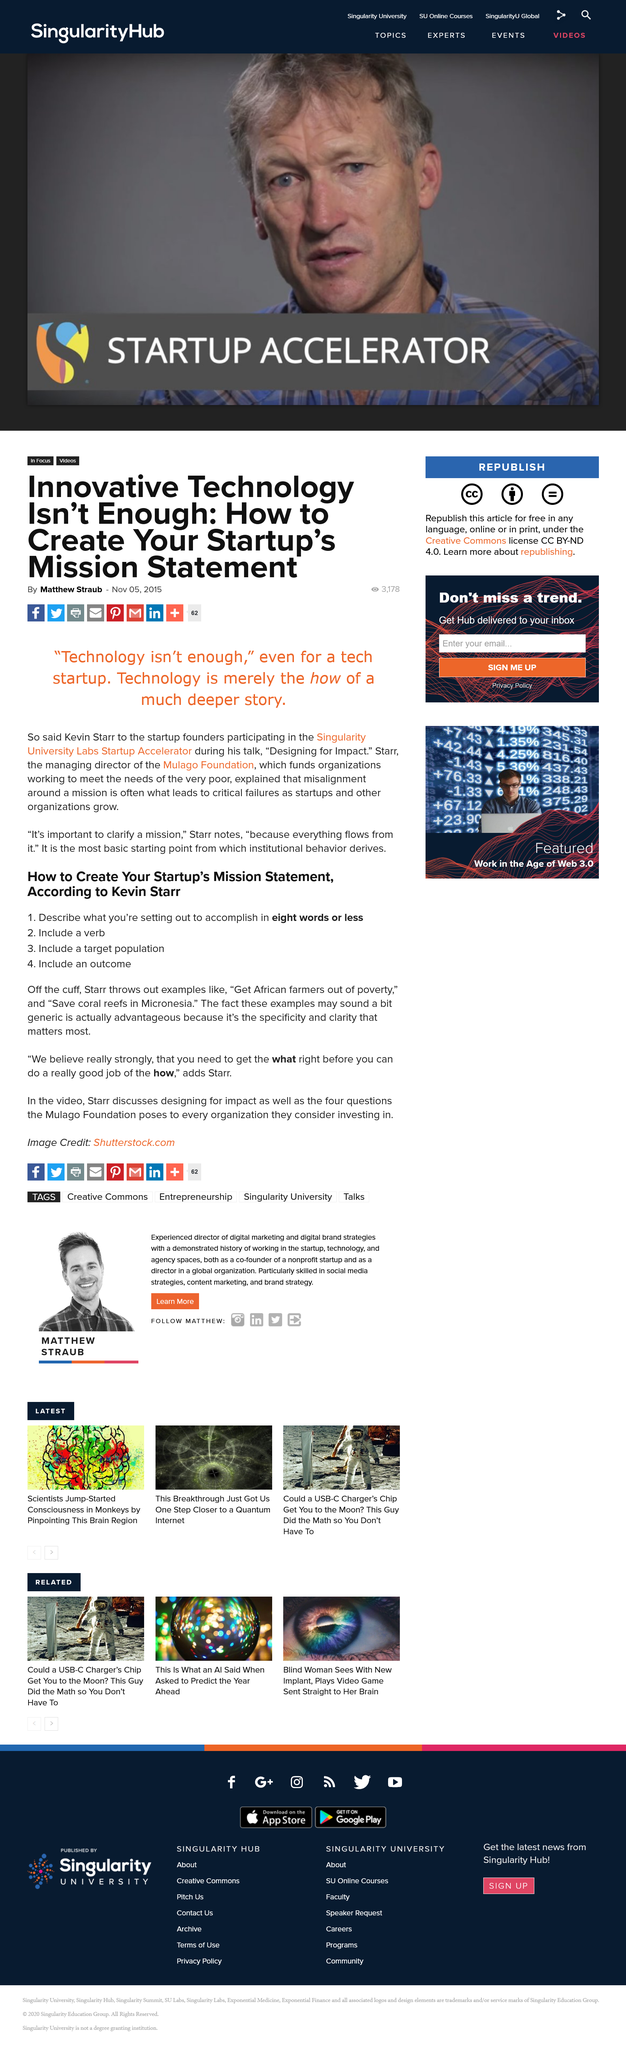Identify some key points in this picture. The Mulago Foundation's mission is to provide funding to organizations focused on addressing the needs of individuals living in extreme poverty. Kevin Starr is the managing director of the Mulago Foundation, which is a foundation that focuses on improving healthcare systems in developing countries. 